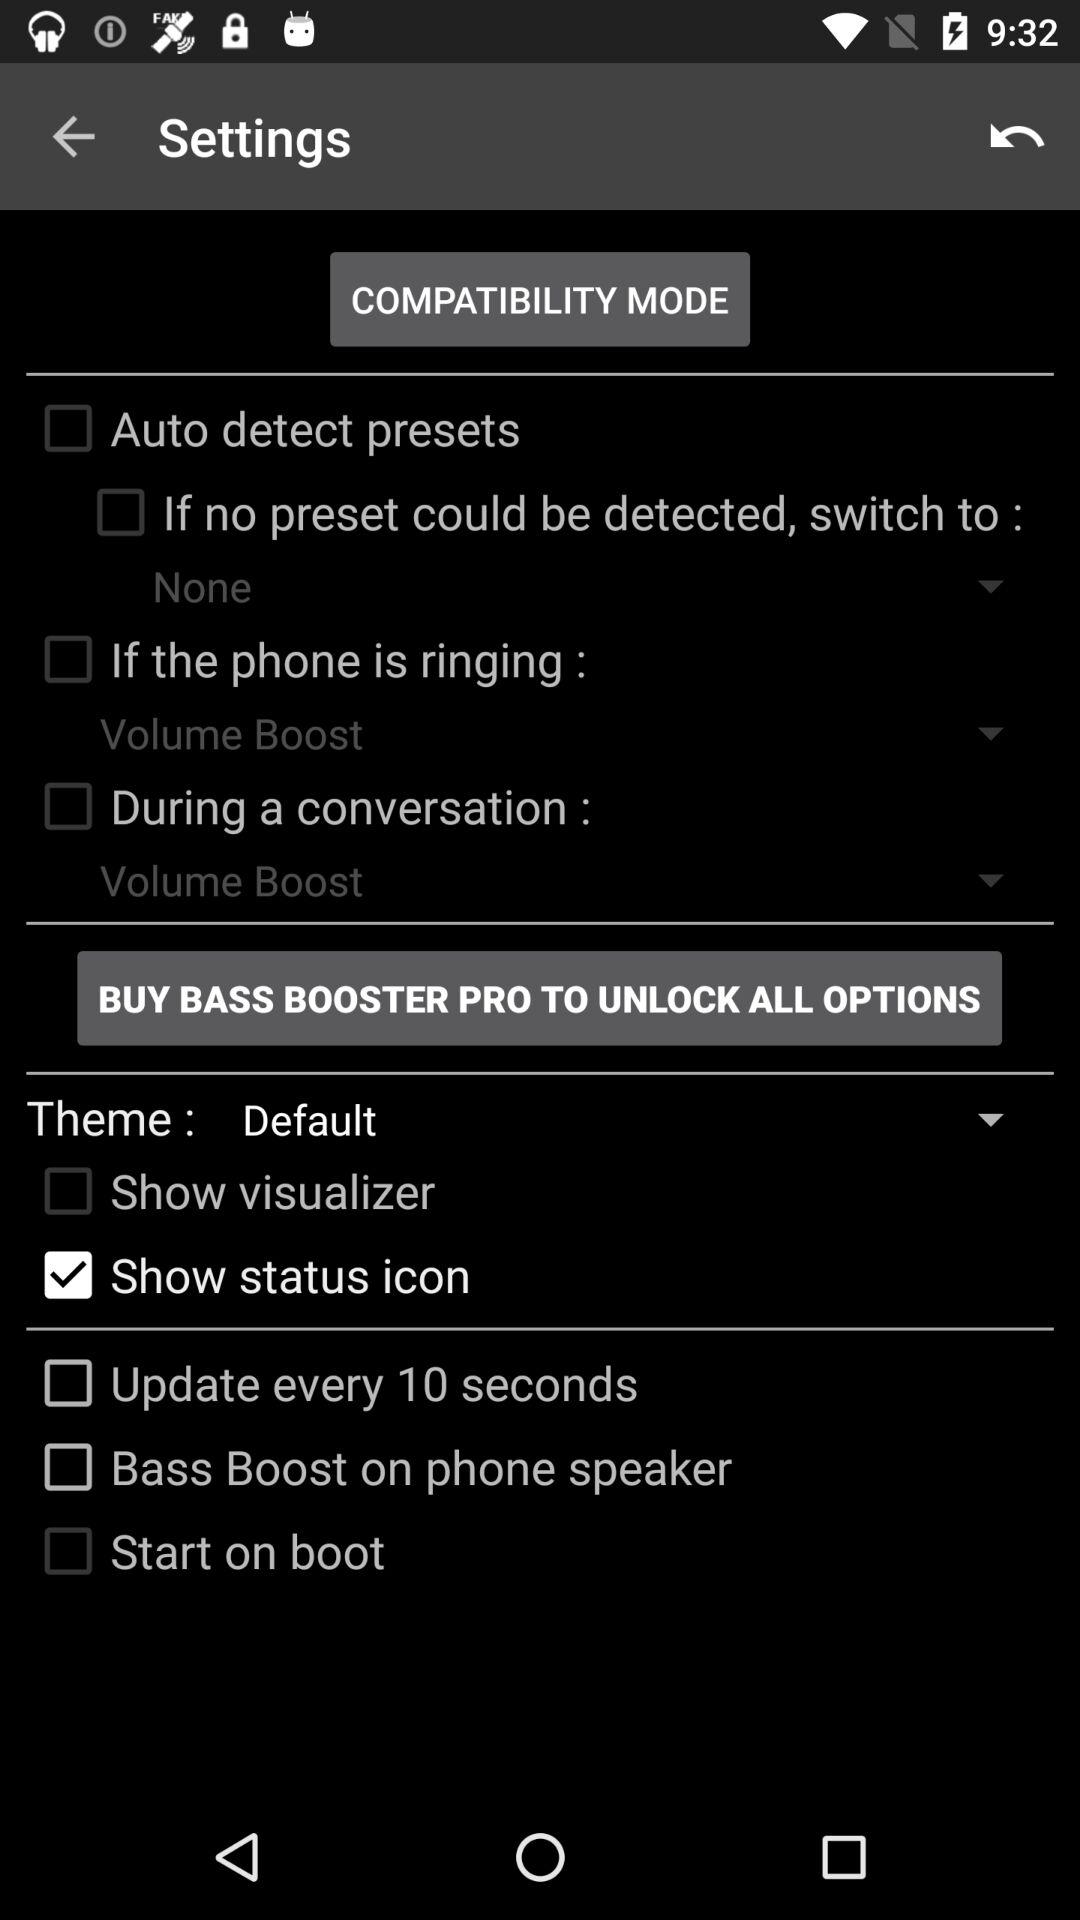What to buy to unlock all options? To unlock all options, buy "BASS BOOSTER PRO". 